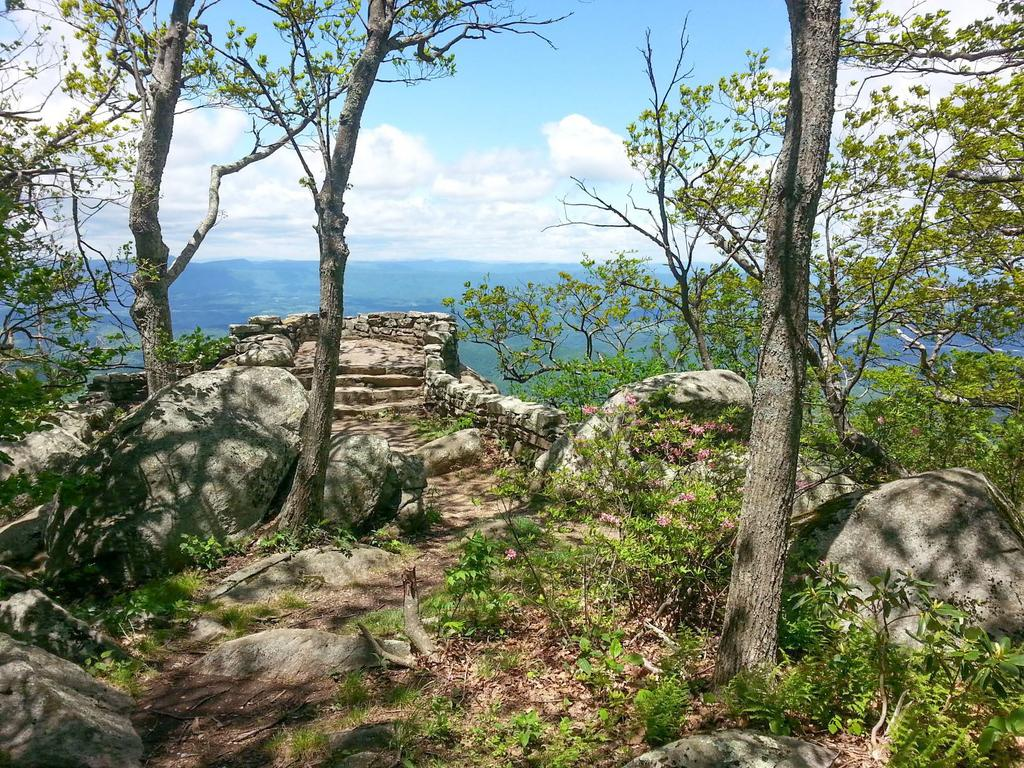What type of natural elements can be seen in the image? There are trees and rocks visible in the image. Are there any man-made structures in the image? Yes, there are steps in the image. What can be seen in the background of the image? Water and the sky are visible in the background of the image. Can you tell me how many yaks are grazing near the water in the image? There are no yaks present in the image; it features trees, rocks, steps, water, and the sky. What type of flame can be seen coming from the rocks in the image? There is no flame present in the image; it only features trees, rocks, steps, water, and the sky. 